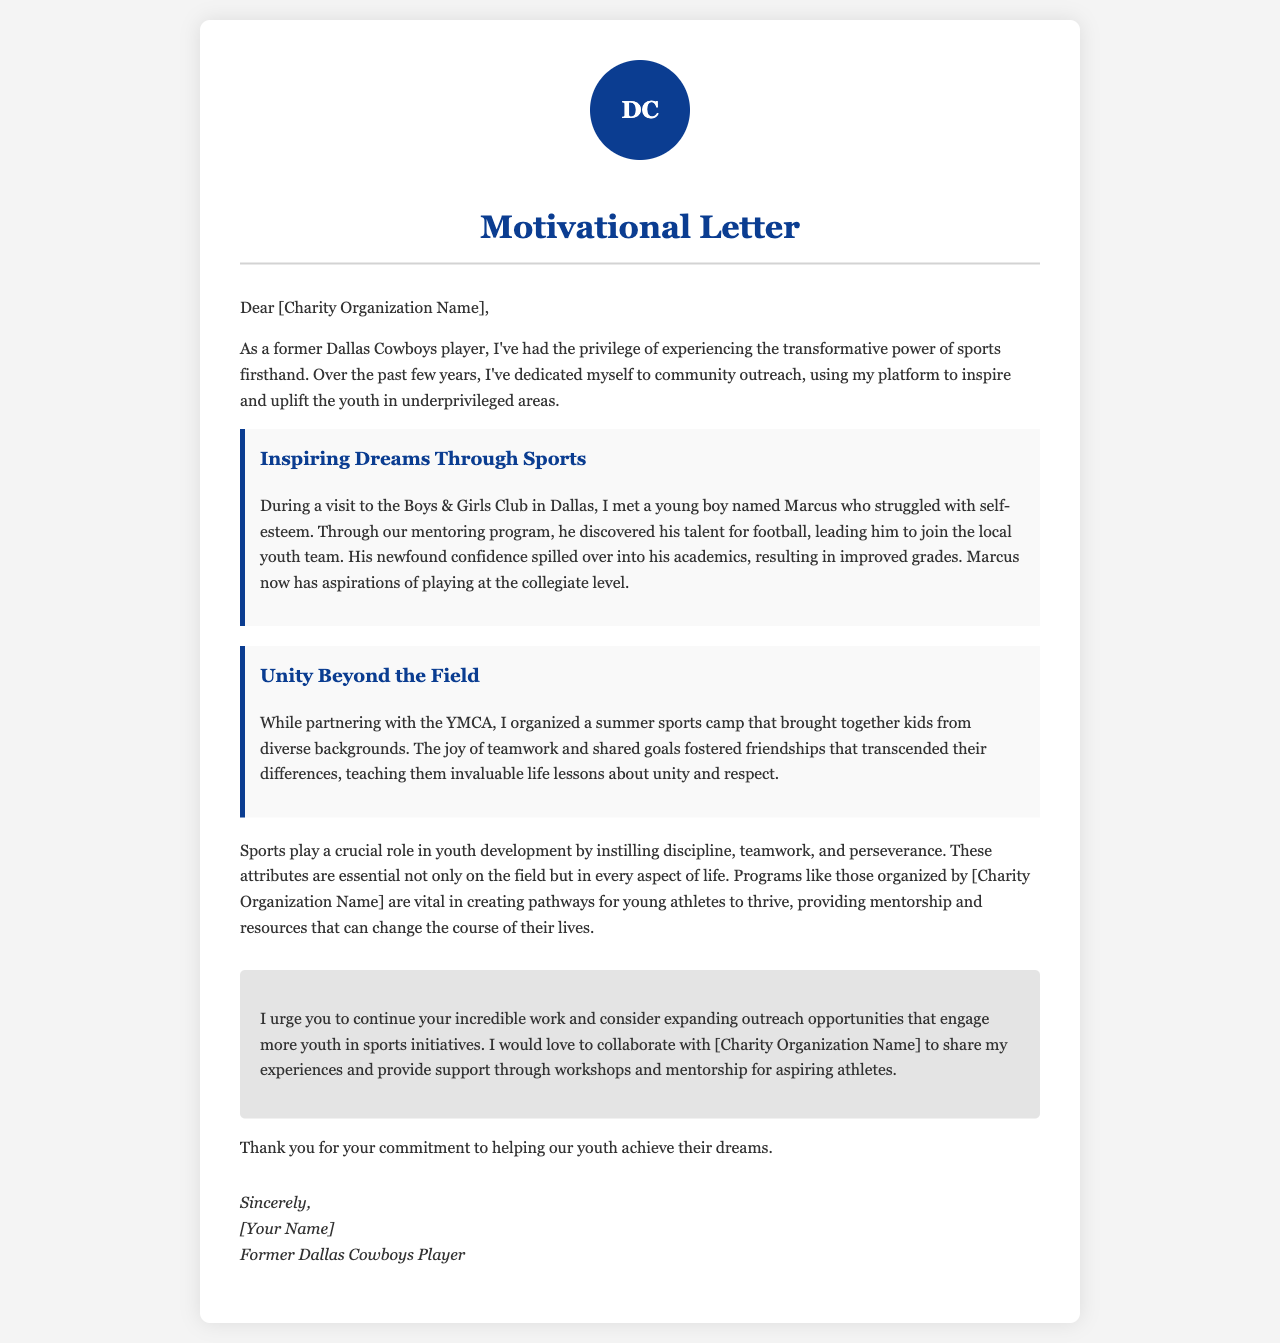What is the name of the organization visited in Dallas? The document mentions a visit to the Boys & Girls Club in Dallas as part of community outreach efforts.
Answer: Boys & Girls Club Who is the young boy highlighted in the letter? The letter shares the story of a young boy named Marcus who discovered his talent for football through mentoring.
Answer: Marcus What impact did the sports camp have on the kids? The letter explains that the summer sports camp fostered friendships and taught invaluable life lessons about unity and respect among kids from diverse backgrounds.
Answer: Unity and respect What does the author encourage the charity organization to do? The author urges the charity organization to expand outreach opportunities that engage more youth in sports initiatives.
Answer: Expand outreach opportunities What position did the author play? The author identifies themselves as a former player of the Dallas Cowboys, suggesting they had a significant role in the sport.
Answer: Player What two attributes do sports instill according to the letter? The author mentions that sports instill discipline and teamwork, which are essential for youth development.
Answer: Discipline and teamwork 